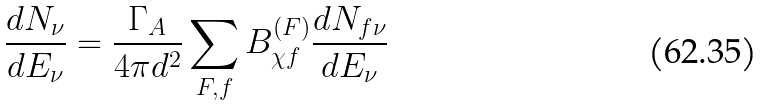Convert formula to latex. <formula><loc_0><loc_0><loc_500><loc_500>\frac { d N _ { \nu } } { d E _ { \nu } } = \frac { \Gamma _ { A } } { 4 \pi d ^ { 2 } } \sum _ { F , f } B _ { \chi f } ^ { ( F ) } \frac { d N _ { f \nu } } { d E _ { \nu } }</formula> 